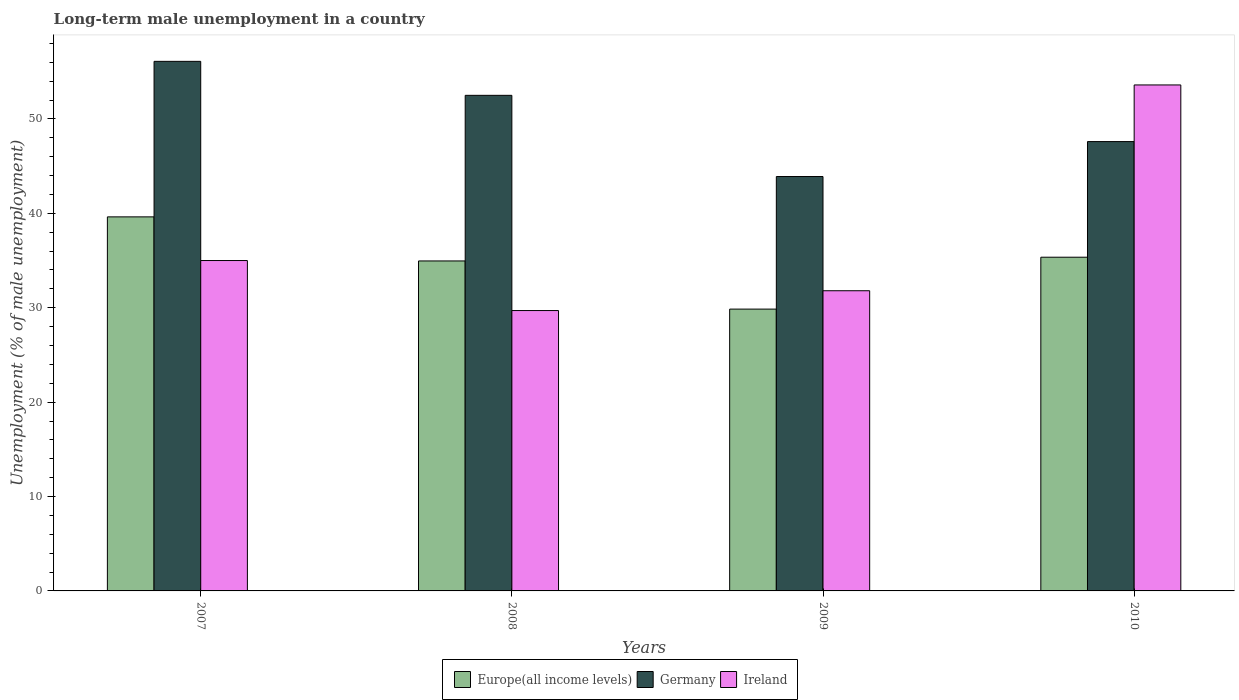Are the number of bars per tick equal to the number of legend labels?
Ensure brevity in your answer.  Yes. How many bars are there on the 3rd tick from the right?
Your answer should be very brief. 3. In how many cases, is the number of bars for a given year not equal to the number of legend labels?
Make the answer very short. 0. What is the percentage of long-term unemployed male population in Germany in 2007?
Ensure brevity in your answer.  56.1. Across all years, what is the maximum percentage of long-term unemployed male population in Ireland?
Offer a terse response. 53.6. Across all years, what is the minimum percentage of long-term unemployed male population in Germany?
Make the answer very short. 43.9. What is the total percentage of long-term unemployed male population in Ireland in the graph?
Provide a short and direct response. 150.1. What is the difference between the percentage of long-term unemployed male population in Europe(all income levels) in 2007 and that in 2010?
Provide a short and direct response. 4.27. What is the difference between the percentage of long-term unemployed male population in Ireland in 2008 and the percentage of long-term unemployed male population in Germany in 2009?
Provide a succinct answer. -14.2. What is the average percentage of long-term unemployed male population in Germany per year?
Give a very brief answer. 50.02. In the year 2009, what is the difference between the percentage of long-term unemployed male population in Ireland and percentage of long-term unemployed male population in Germany?
Offer a very short reply. -12.1. What is the ratio of the percentage of long-term unemployed male population in Ireland in 2008 to that in 2009?
Ensure brevity in your answer.  0.93. Is the difference between the percentage of long-term unemployed male population in Ireland in 2009 and 2010 greater than the difference between the percentage of long-term unemployed male population in Germany in 2009 and 2010?
Your response must be concise. No. What is the difference between the highest and the second highest percentage of long-term unemployed male population in Ireland?
Give a very brief answer. 18.6. What is the difference between the highest and the lowest percentage of long-term unemployed male population in Ireland?
Provide a succinct answer. 23.9. In how many years, is the percentage of long-term unemployed male population in Germany greater than the average percentage of long-term unemployed male population in Germany taken over all years?
Ensure brevity in your answer.  2. Is the sum of the percentage of long-term unemployed male population in Germany in 2009 and 2010 greater than the maximum percentage of long-term unemployed male population in Ireland across all years?
Your answer should be compact. Yes. What does the 1st bar from the right in 2009 represents?
Offer a very short reply. Ireland. Is it the case that in every year, the sum of the percentage of long-term unemployed male population in Germany and percentage of long-term unemployed male population in Ireland is greater than the percentage of long-term unemployed male population in Europe(all income levels)?
Your response must be concise. Yes. How many bars are there?
Offer a very short reply. 12. Are all the bars in the graph horizontal?
Provide a succinct answer. No. What is the difference between two consecutive major ticks on the Y-axis?
Your answer should be very brief. 10. How many legend labels are there?
Keep it short and to the point. 3. What is the title of the graph?
Provide a succinct answer. Long-term male unemployment in a country. Does "Oman" appear as one of the legend labels in the graph?
Make the answer very short. No. What is the label or title of the X-axis?
Provide a succinct answer. Years. What is the label or title of the Y-axis?
Keep it short and to the point. Unemployment (% of male unemployment). What is the Unemployment (% of male unemployment) in Europe(all income levels) in 2007?
Your answer should be compact. 39.63. What is the Unemployment (% of male unemployment) of Germany in 2007?
Your response must be concise. 56.1. What is the Unemployment (% of male unemployment) in Europe(all income levels) in 2008?
Keep it short and to the point. 34.96. What is the Unemployment (% of male unemployment) in Germany in 2008?
Your answer should be compact. 52.5. What is the Unemployment (% of male unemployment) in Ireland in 2008?
Your answer should be very brief. 29.7. What is the Unemployment (% of male unemployment) of Europe(all income levels) in 2009?
Offer a very short reply. 29.85. What is the Unemployment (% of male unemployment) in Germany in 2009?
Ensure brevity in your answer.  43.9. What is the Unemployment (% of male unemployment) of Ireland in 2009?
Provide a short and direct response. 31.8. What is the Unemployment (% of male unemployment) of Europe(all income levels) in 2010?
Give a very brief answer. 35.35. What is the Unemployment (% of male unemployment) of Germany in 2010?
Your answer should be compact. 47.6. What is the Unemployment (% of male unemployment) in Ireland in 2010?
Offer a very short reply. 53.6. Across all years, what is the maximum Unemployment (% of male unemployment) of Europe(all income levels)?
Offer a terse response. 39.63. Across all years, what is the maximum Unemployment (% of male unemployment) in Germany?
Offer a terse response. 56.1. Across all years, what is the maximum Unemployment (% of male unemployment) of Ireland?
Provide a succinct answer. 53.6. Across all years, what is the minimum Unemployment (% of male unemployment) in Europe(all income levels)?
Provide a short and direct response. 29.85. Across all years, what is the minimum Unemployment (% of male unemployment) of Germany?
Your answer should be compact. 43.9. Across all years, what is the minimum Unemployment (% of male unemployment) of Ireland?
Provide a short and direct response. 29.7. What is the total Unemployment (% of male unemployment) in Europe(all income levels) in the graph?
Offer a terse response. 139.79. What is the total Unemployment (% of male unemployment) of Germany in the graph?
Offer a terse response. 200.1. What is the total Unemployment (% of male unemployment) of Ireland in the graph?
Your response must be concise. 150.1. What is the difference between the Unemployment (% of male unemployment) of Europe(all income levels) in 2007 and that in 2008?
Your answer should be compact. 4.67. What is the difference between the Unemployment (% of male unemployment) in Europe(all income levels) in 2007 and that in 2009?
Provide a short and direct response. 9.77. What is the difference between the Unemployment (% of male unemployment) of Germany in 2007 and that in 2009?
Provide a short and direct response. 12.2. What is the difference between the Unemployment (% of male unemployment) in Ireland in 2007 and that in 2009?
Keep it short and to the point. 3.2. What is the difference between the Unemployment (% of male unemployment) in Europe(all income levels) in 2007 and that in 2010?
Your answer should be very brief. 4.27. What is the difference between the Unemployment (% of male unemployment) of Ireland in 2007 and that in 2010?
Ensure brevity in your answer.  -18.6. What is the difference between the Unemployment (% of male unemployment) of Europe(all income levels) in 2008 and that in 2009?
Provide a short and direct response. 5.1. What is the difference between the Unemployment (% of male unemployment) of Germany in 2008 and that in 2009?
Your answer should be compact. 8.6. What is the difference between the Unemployment (% of male unemployment) of Europe(all income levels) in 2008 and that in 2010?
Offer a very short reply. -0.4. What is the difference between the Unemployment (% of male unemployment) in Germany in 2008 and that in 2010?
Provide a succinct answer. 4.9. What is the difference between the Unemployment (% of male unemployment) in Ireland in 2008 and that in 2010?
Your response must be concise. -23.9. What is the difference between the Unemployment (% of male unemployment) of Europe(all income levels) in 2009 and that in 2010?
Offer a terse response. -5.5. What is the difference between the Unemployment (% of male unemployment) in Ireland in 2009 and that in 2010?
Your answer should be compact. -21.8. What is the difference between the Unemployment (% of male unemployment) of Europe(all income levels) in 2007 and the Unemployment (% of male unemployment) of Germany in 2008?
Your answer should be very brief. -12.87. What is the difference between the Unemployment (% of male unemployment) of Europe(all income levels) in 2007 and the Unemployment (% of male unemployment) of Ireland in 2008?
Provide a succinct answer. 9.93. What is the difference between the Unemployment (% of male unemployment) in Germany in 2007 and the Unemployment (% of male unemployment) in Ireland in 2008?
Give a very brief answer. 26.4. What is the difference between the Unemployment (% of male unemployment) of Europe(all income levels) in 2007 and the Unemployment (% of male unemployment) of Germany in 2009?
Offer a very short reply. -4.27. What is the difference between the Unemployment (% of male unemployment) in Europe(all income levels) in 2007 and the Unemployment (% of male unemployment) in Ireland in 2009?
Provide a short and direct response. 7.83. What is the difference between the Unemployment (% of male unemployment) in Germany in 2007 and the Unemployment (% of male unemployment) in Ireland in 2009?
Offer a terse response. 24.3. What is the difference between the Unemployment (% of male unemployment) in Europe(all income levels) in 2007 and the Unemployment (% of male unemployment) in Germany in 2010?
Your answer should be compact. -7.97. What is the difference between the Unemployment (% of male unemployment) in Europe(all income levels) in 2007 and the Unemployment (% of male unemployment) in Ireland in 2010?
Provide a short and direct response. -13.97. What is the difference between the Unemployment (% of male unemployment) of Europe(all income levels) in 2008 and the Unemployment (% of male unemployment) of Germany in 2009?
Give a very brief answer. -8.94. What is the difference between the Unemployment (% of male unemployment) in Europe(all income levels) in 2008 and the Unemployment (% of male unemployment) in Ireland in 2009?
Keep it short and to the point. 3.16. What is the difference between the Unemployment (% of male unemployment) in Germany in 2008 and the Unemployment (% of male unemployment) in Ireland in 2009?
Your answer should be compact. 20.7. What is the difference between the Unemployment (% of male unemployment) of Europe(all income levels) in 2008 and the Unemployment (% of male unemployment) of Germany in 2010?
Offer a very short reply. -12.64. What is the difference between the Unemployment (% of male unemployment) of Europe(all income levels) in 2008 and the Unemployment (% of male unemployment) of Ireland in 2010?
Offer a very short reply. -18.64. What is the difference between the Unemployment (% of male unemployment) in Europe(all income levels) in 2009 and the Unemployment (% of male unemployment) in Germany in 2010?
Give a very brief answer. -17.75. What is the difference between the Unemployment (% of male unemployment) of Europe(all income levels) in 2009 and the Unemployment (% of male unemployment) of Ireland in 2010?
Offer a very short reply. -23.75. What is the average Unemployment (% of male unemployment) of Europe(all income levels) per year?
Give a very brief answer. 34.95. What is the average Unemployment (% of male unemployment) in Germany per year?
Ensure brevity in your answer.  50.02. What is the average Unemployment (% of male unemployment) of Ireland per year?
Give a very brief answer. 37.52. In the year 2007, what is the difference between the Unemployment (% of male unemployment) in Europe(all income levels) and Unemployment (% of male unemployment) in Germany?
Give a very brief answer. -16.47. In the year 2007, what is the difference between the Unemployment (% of male unemployment) in Europe(all income levels) and Unemployment (% of male unemployment) in Ireland?
Provide a succinct answer. 4.63. In the year 2007, what is the difference between the Unemployment (% of male unemployment) in Germany and Unemployment (% of male unemployment) in Ireland?
Provide a succinct answer. 21.1. In the year 2008, what is the difference between the Unemployment (% of male unemployment) of Europe(all income levels) and Unemployment (% of male unemployment) of Germany?
Ensure brevity in your answer.  -17.54. In the year 2008, what is the difference between the Unemployment (% of male unemployment) in Europe(all income levels) and Unemployment (% of male unemployment) in Ireland?
Your answer should be compact. 5.26. In the year 2008, what is the difference between the Unemployment (% of male unemployment) in Germany and Unemployment (% of male unemployment) in Ireland?
Give a very brief answer. 22.8. In the year 2009, what is the difference between the Unemployment (% of male unemployment) of Europe(all income levels) and Unemployment (% of male unemployment) of Germany?
Offer a very short reply. -14.05. In the year 2009, what is the difference between the Unemployment (% of male unemployment) in Europe(all income levels) and Unemployment (% of male unemployment) in Ireland?
Provide a succinct answer. -1.95. In the year 2009, what is the difference between the Unemployment (% of male unemployment) of Germany and Unemployment (% of male unemployment) of Ireland?
Keep it short and to the point. 12.1. In the year 2010, what is the difference between the Unemployment (% of male unemployment) in Europe(all income levels) and Unemployment (% of male unemployment) in Germany?
Provide a succinct answer. -12.25. In the year 2010, what is the difference between the Unemployment (% of male unemployment) in Europe(all income levels) and Unemployment (% of male unemployment) in Ireland?
Provide a succinct answer. -18.25. In the year 2010, what is the difference between the Unemployment (% of male unemployment) of Germany and Unemployment (% of male unemployment) of Ireland?
Your answer should be very brief. -6. What is the ratio of the Unemployment (% of male unemployment) in Europe(all income levels) in 2007 to that in 2008?
Provide a succinct answer. 1.13. What is the ratio of the Unemployment (% of male unemployment) in Germany in 2007 to that in 2008?
Make the answer very short. 1.07. What is the ratio of the Unemployment (% of male unemployment) in Ireland in 2007 to that in 2008?
Provide a succinct answer. 1.18. What is the ratio of the Unemployment (% of male unemployment) in Europe(all income levels) in 2007 to that in 2009?
Your response must be concise. 1.33. What is the ratio of the Unemployment (% of male unemployment) in Germany in 2007 to that in 2009?
Make the answer very short. 1.28. What is the ratio of the Unemployment (% of male unemployment) of Ireland in 2007 to that in 2009?
Make the answer very short. 1.1. What is the ratio of the Unemployment (% of male unemployment) of Europe(all income levels) in 2007 to that in 2010?
Ensure brevity in your answer.  1.12. What is the ratio of the Unemployment (% of male unemployment) of Germany in 2007 to that in 2010?
Offer a very short reply. 1.18. What is the ratio of the Unemployment (% of male unemployment) of Ireland in 2007 to that in 2010?
Give a very brief answer. 0.65. What is the ratio of the Unemployment (% of male unemployment) of Europe(all income levels) in 2008 to that in 2009?
Ensure brevity in your answer.  1.17. What is the ratio of the Unemployment (% of male unemployment) in Germany in 2008 to that in 2009?
Offer a terse response. 1.2. What is the ratio of the Unemployment (% of male unemployment) in Ireland in 2008 to that in 2009?
Provide a short and direct response. 0.93. What is the ratio of the Unemployment (% of male unemployment) in Germany in 2008 to that in 2010?
Provide a succinct answer. 1.1. What is the ratio of the Unemployment (% of male unemployment) in Ireland in 2008 to that in 2010?
Keep it short and to the point. 0.55. What is the ratio of the Unemployment (% of male unemployment) in Europe(all income levels) in 2009 to that in 2010?
Your answer should be compact. 0.84. What is the ratio of the Unemployment (% of male unemployment) in Germany in 2009 to that in 2010?
Offer a very short reply. 0.92. What is the ratio of the Unemployment (% of male unemployment) in Ireland in 2009 to that in 2010?
Provide a short and direct response. 0.59. What is the difference between the highest and the second highest Unemployment (% of male unemployment) in Europe(all income levels)?
Your response must be concise. 4.27. What is the difference between the highest and the second highest Unemployment (% of male unemployment) of Germany?
Ensure brevity in your answer.  3.6. What is the difference between the highest and the lowest Unemployment (% of male unemployment) of Europe(all income levels)?
Your answer should be very brief. 9.77. What is the difference between the highest and the lowest Unemployment (% of male unemployment) in Germany?
Provide a short and direct response. 12.2. What is the difference between the highest and the lowest Unemployment (% of male unemployment) of Ireland?
Your answer should be compact. 23.9. 